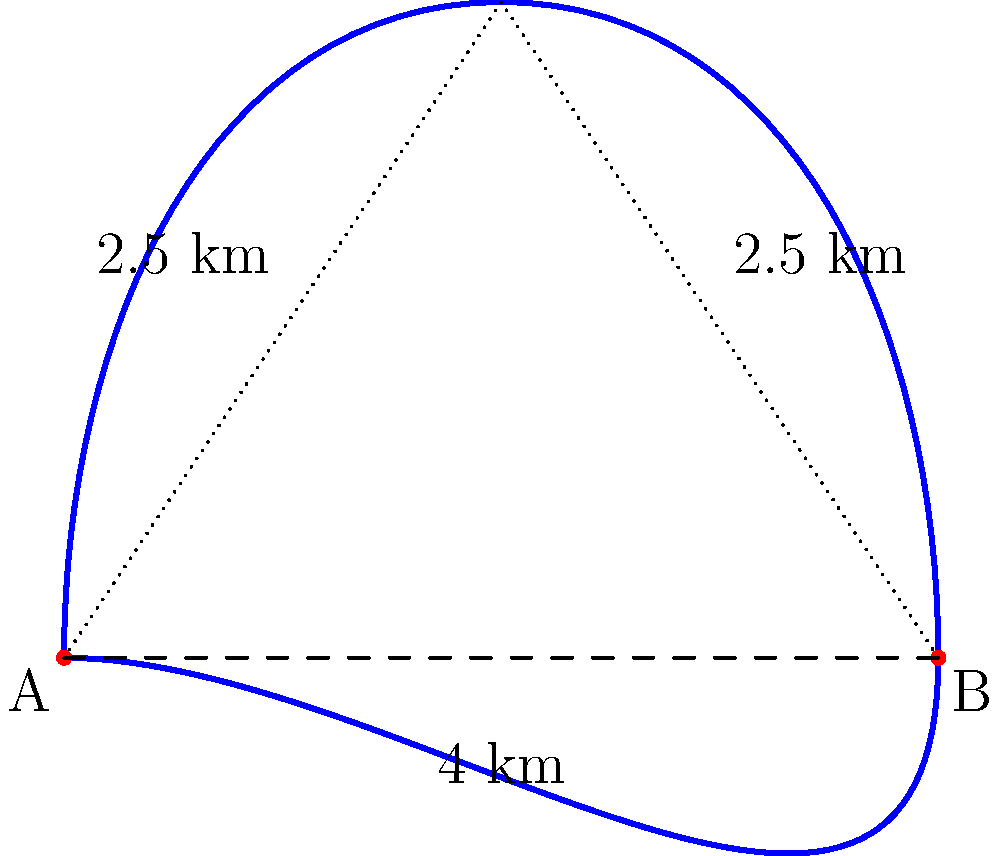As a geological tour guide in Tanzania, you're tasked with estimating the perimeter of a newly designated national park with curved boundaries. The park's shape is roughly represented by the blue curve in the diagram. Given that the straight-line distance between points A and B is 4 km, and the dotted lines forming a triangle with the base AB are each 2.5 km long, estimate the perimeter of the park to the nearest kilometer. To estimate the perimeter of the national park with curved edges, we'll follow these steps:

1) First, we need to estimate the length of the curved sections. We can do this by comparing them to the straight lines we know:

   - The bottom straight line (AB) is 4 km.
   - Each side of the triangle formed by the dotted lines is 2.5 km.

2) The curved path is longer than the straight line but shorter than going around two sides of the triangle.

3) Let's estimate each curved section (top and bottom) to be about 3 km:
   
   - This is less than the sum of two triangle sides (2.5 + 2.5 = 5 km)
   - But more than the straight line (4 km)

4) Now we can estimate the total perimeter:

   $\text{Estimated Perimeter} \approx 3 \text{ km (top curve)} + 3 \text{ km (bottom curve)} = 6 \text{ km}$

5) Rounding to the nearest kilometer, our estimate remains 6 km.

This method provides a reasonable estimate based on the given information and the shape of the park boundary.
Answer: 6 km 